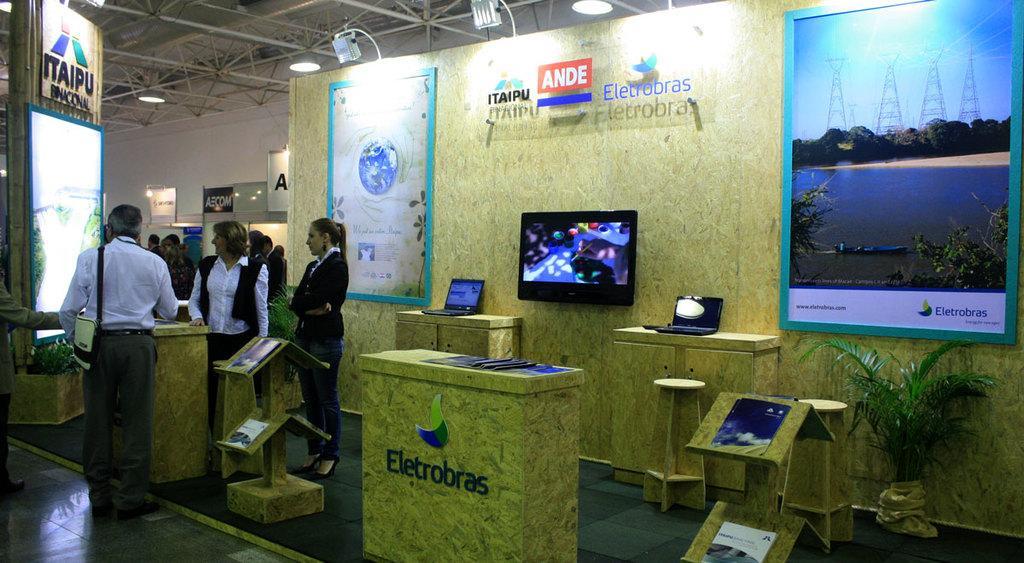In one or two sentences, can you explain what this image depicts? This picture is clicked inside the hall. On the left we can see the group of people standing on the ground and we can see a person wearing a sling bag and standing on the ground and we can see the tables on the top of which laptops and some pamphlets are placed and we can see the racks containing some objects which seems to be the books and we can see the text and some depictions of some objects on the covers of the books. On the right we can see the plant. In the background we can see the text on the wall and we can see the posts containing the text and the depictions of the sky, metal rods, trees, water body and some objects. At the top we can see the roof, metal rods, lights. On the left we can see the plant and some other objects. 